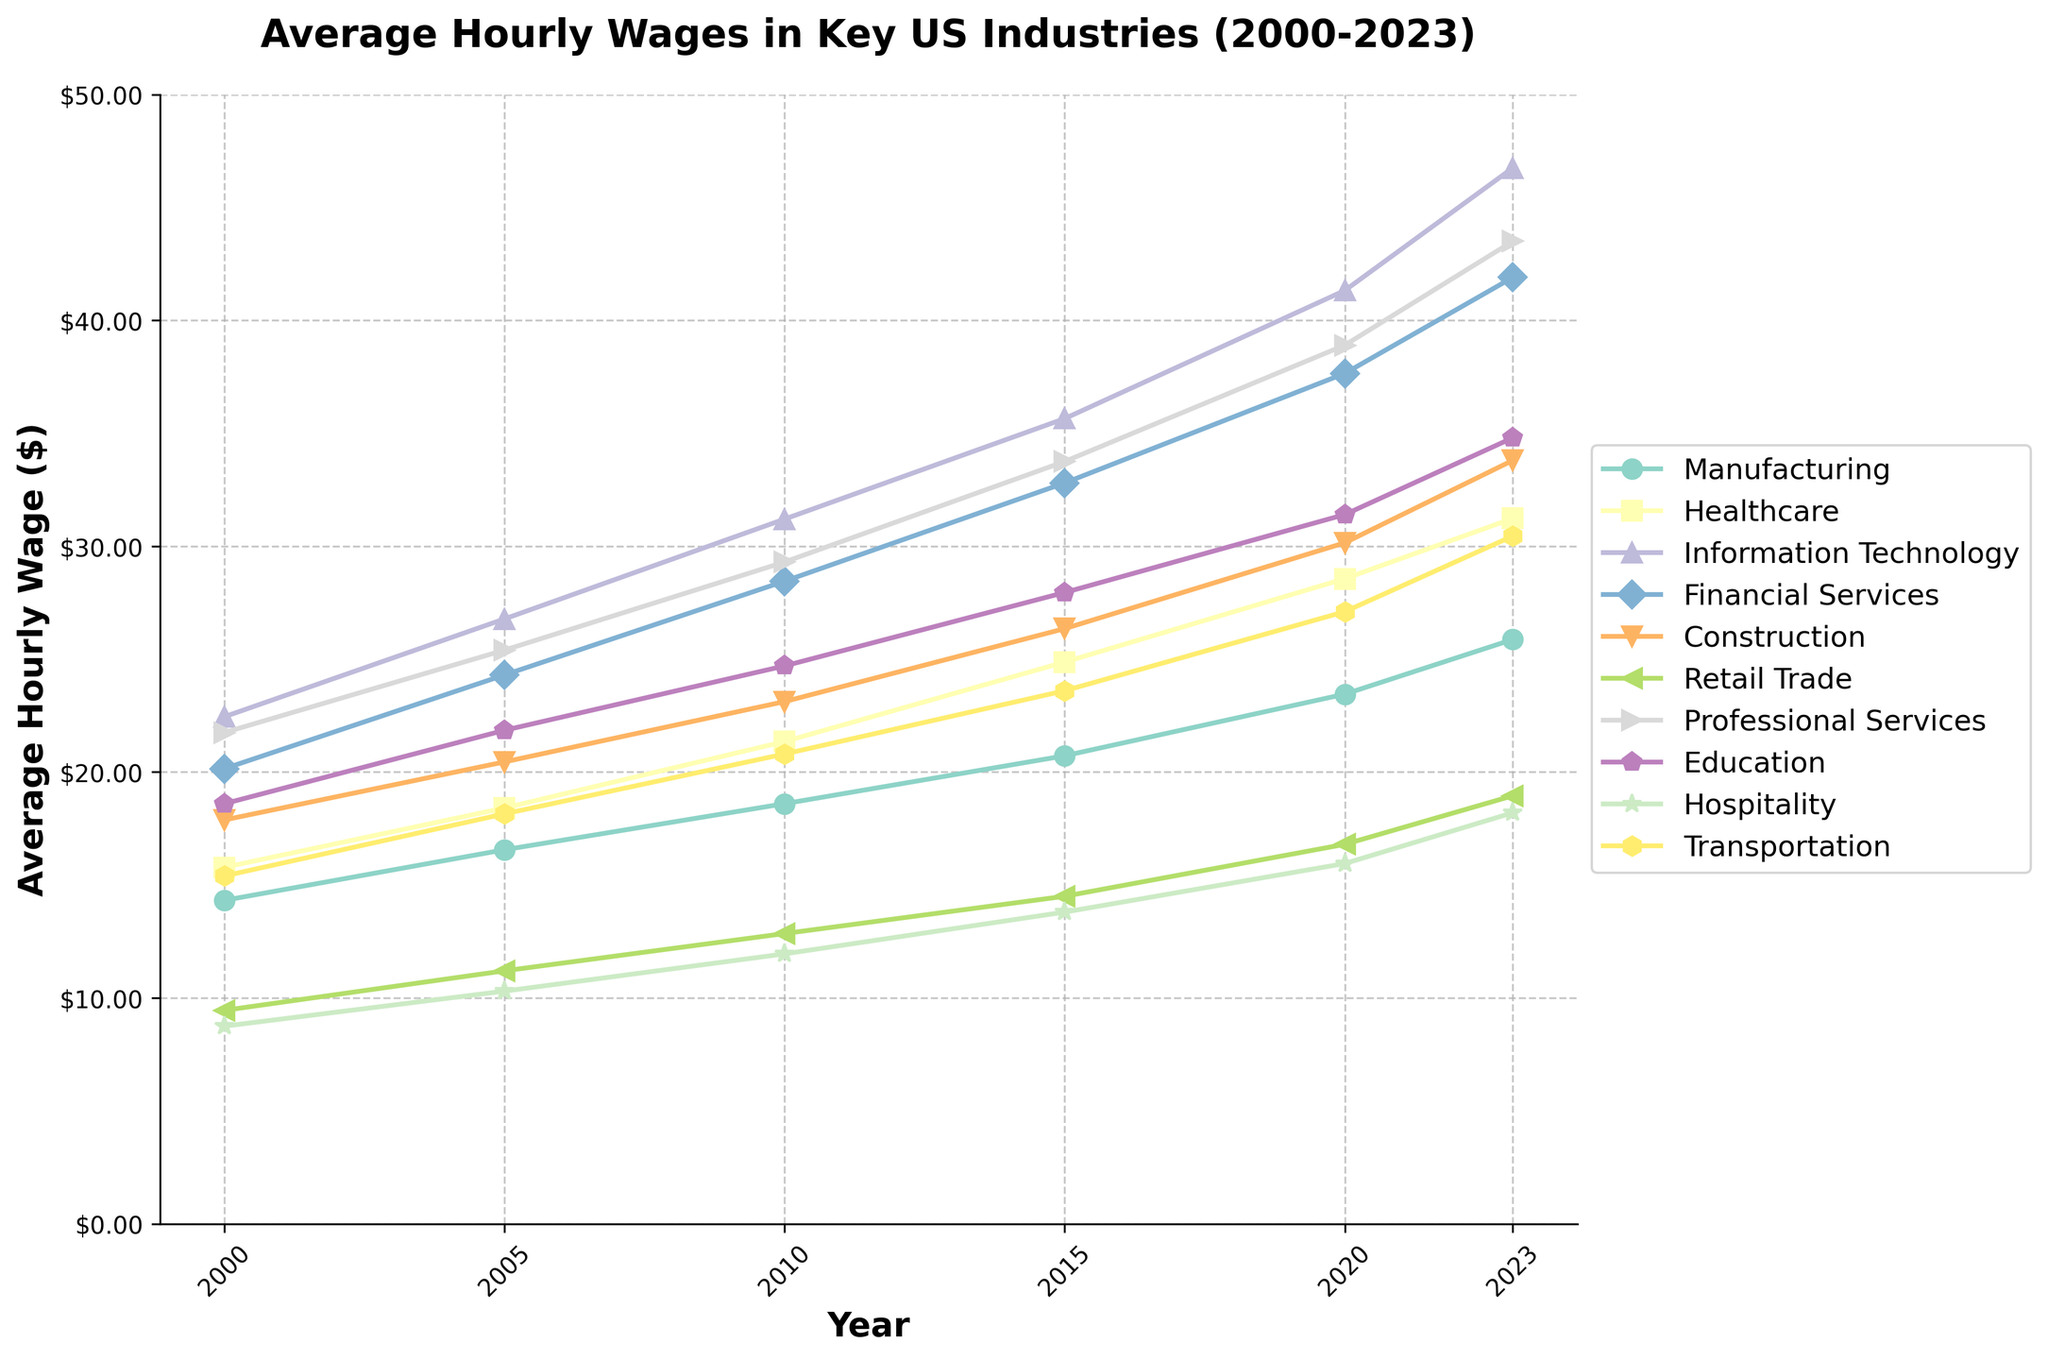What is the trend in average hourly wages for the Healthcare industry from 2000 to 2023? Notice that the line representing Healthcare increases consistently from 2000 ($15.78) to 2023 ($31.23). The trend is upward throughout the entire period.
Answer: Upward Which industry shows the highest increase in average hourly wages between 2000 and 2023? To determine this, calculate the difference between the 2023 and 2000 values for each industry. Information Technology has the maximum increase, going from $22.45 in 2000 to $46.75 in 2023, an increase of $24.30.
Answer: Information Technology What is the difference in average hourly wages between the Construction and Retail Trade industries in 2023? In 2023, Construction's average hourly wage is $33.80 and Retail Trade's is $18.95. The difference is $33.80 - $18.95 = $14.85.
Answer: $14.85 Which year shows the smallest gap between the average hourly wages of Manufacturing and Healthcare? Check the differences per year: 
2000: $15.78 - $14.32 = $1.46, 
2005: $18.41 - $16.56 = $1.85, 
2010: $21.35 - $18.60 = $2.75, 
2015: $24.87 - $20.72 = $4.15, 
2020: $28.56 - $23.45 = $5.11, 
2023: $31.23 - $25.87 = $5.36. 
The smallest gap is in 2000 with a difference of $1.46.
Answer: 2000 By how much did the average hourly wages in the Education industry increase each year on average from 2000 to 2023? Calculate the total increase in hourly wages from 2000 to 2023. The initial wage was $18.60, and the final wage is $34.80, so $34.80 - $18.60 = $16.20 over 23 years. Divide by 23 years: $16.20 / 23 ≈ $0.70 per year.
Answer: $0.70 Which industry had the highest average hourly wage in 2010? Look at the 2010 column. Information Technology had the highest value at $31.20, followed by Financial Services ($28.45).
Answer: Information Technology Is there any year when the Hospitality industry's average hourly wages surpassed those of Retail Trade? Examine the wages year-by-year for Hospitality and Retail Trade. In all years, Retail Trade wages are higher than those in the Hospitality industry.
Answer: No What's the overall trend observed for the average hourly wages in the Transportation industry? From 2000 ($15.40) to 2023 ($30.45), the average hourly wages for Transportation have steadily increased each year.
Answer: Increasing Compare the average hourly wages of Professional Services in 2000 and 2015. What is the increase? In 2000, it was $21.75, and in 2015, it was $33.75. The increase is $33.75 - $21.75 = $12.00.
Answer: $12.00 By how much did the average hourly wage in the Financial Services industry grow from 2010 to 2023? In 2010, it was $28.45. By 2023, it was $41.90. The growth is $41.90 - $28.45 = $13.45.
Answer: $13.45 